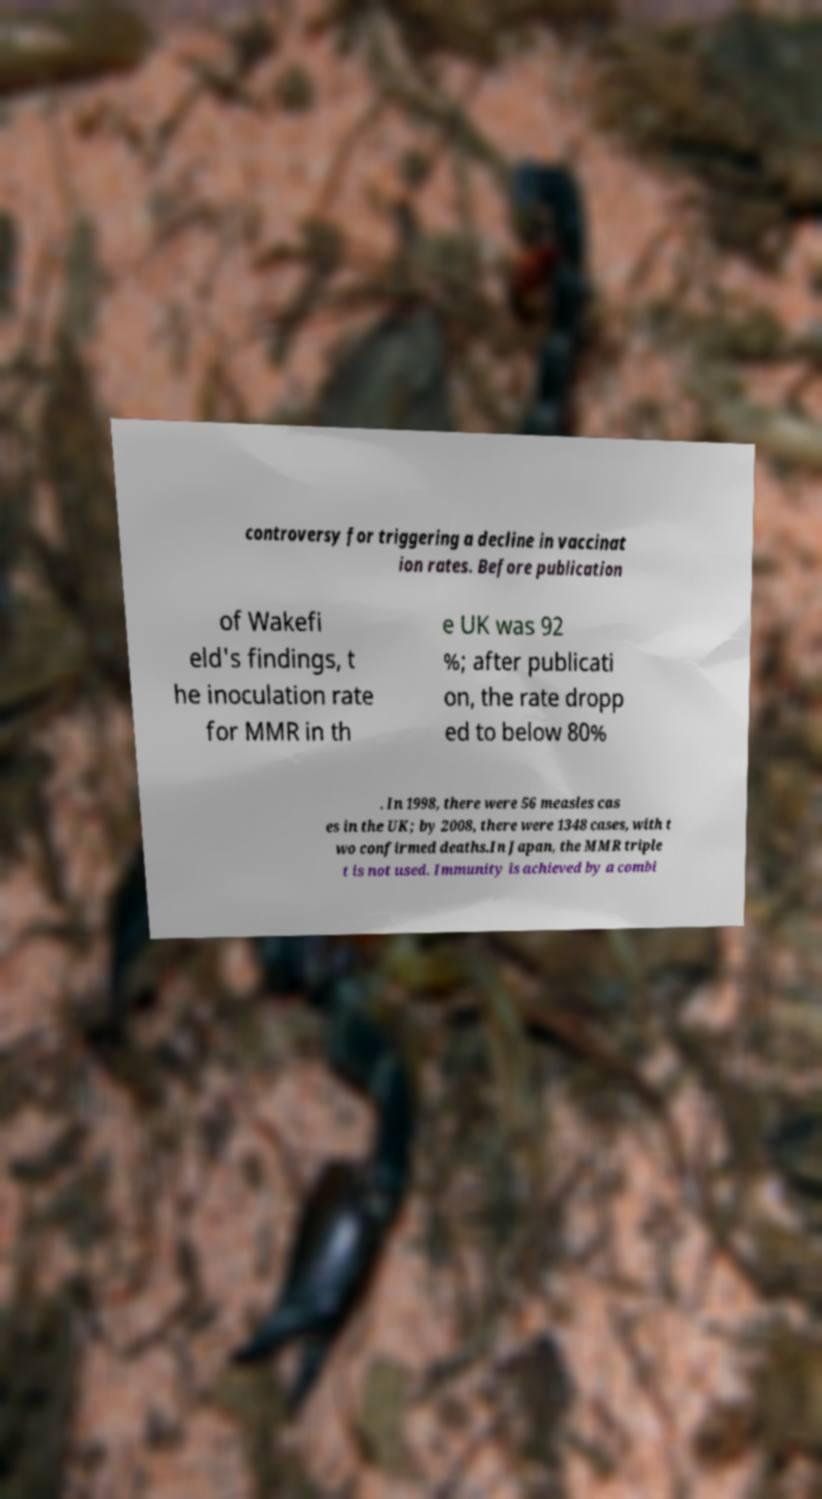Can you accurately transcribe the text from the provided image for me? controversy for triggering a decline in vaccinat ion rates. Before publication of Wakefi eld's findings, t he inoculation rate for MMR in th e UK was 92 %; after publicati on, the rate dropp ed to below 80% . In 1998, there were 56 measles cas es in the UK; by 2008, there were 1348 cases, with t wo confirmed deaths.In Japan, the MMR triple t is not used. Immunity is achieved by a combi 